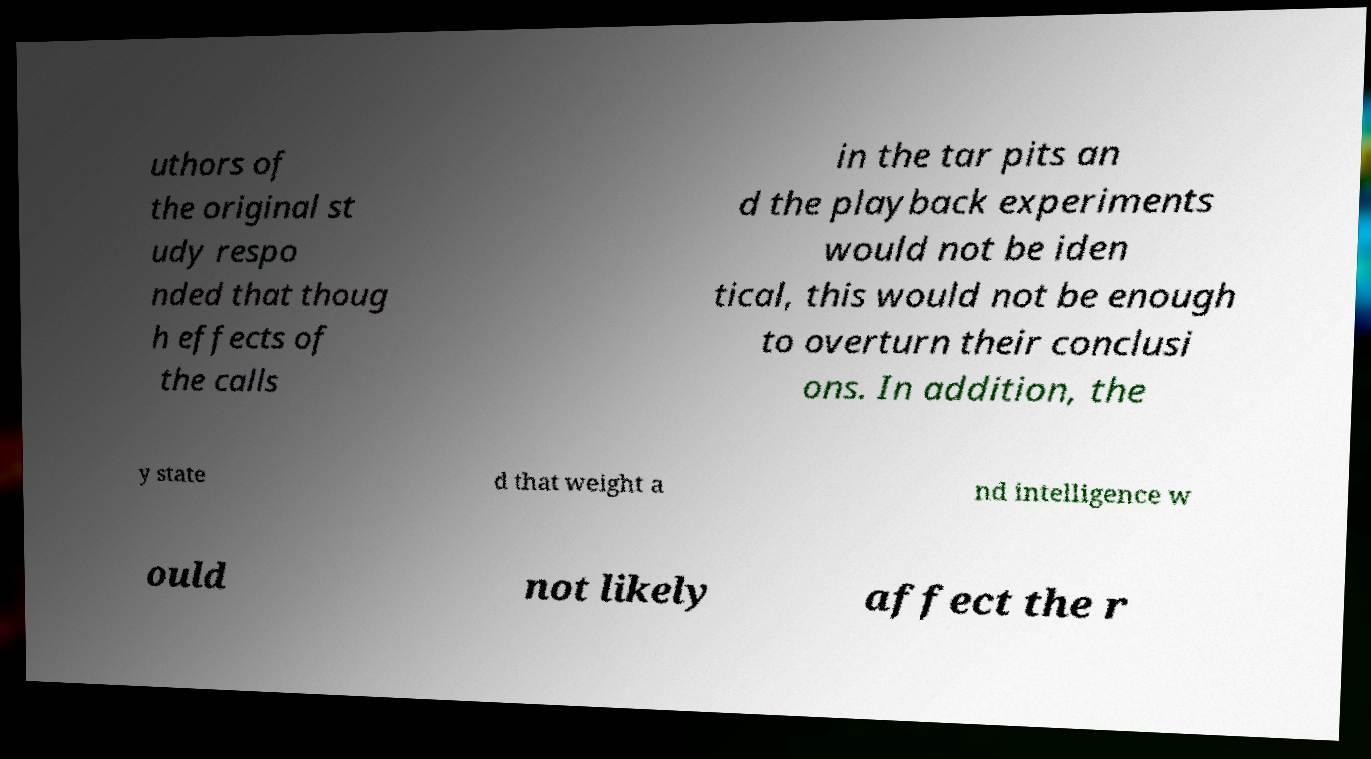Please identify and transcribe the text found in this image. uthors of the original st udy respo nded that thoug h effects of the calls in the tar pits an d the playback experiments would not be iden tical, this would not be enough to overturn their conclusi ons. In addition, the y state d that weight a nd intelligence w ould not likely affect the r 